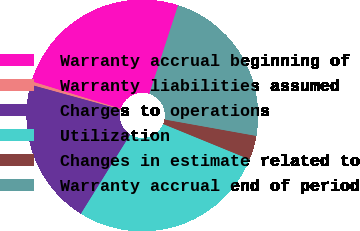<chart> <loc_0><loc_0><loc_500><loc_500><pie_chart><fcel>Warranty accrual beginning of<fcel>Warranty liabilities assumed<fcel>Charges to operations<fcel>Utilization<fcel>Changes in estimate related to<fcel>Warranty accrual end of period<nl><fcel>25.26%<fcel>0.48%<fcel>20.39%<fcel>27.69%<fcel>3.36%<fcel>22.82%<nl></chart> 